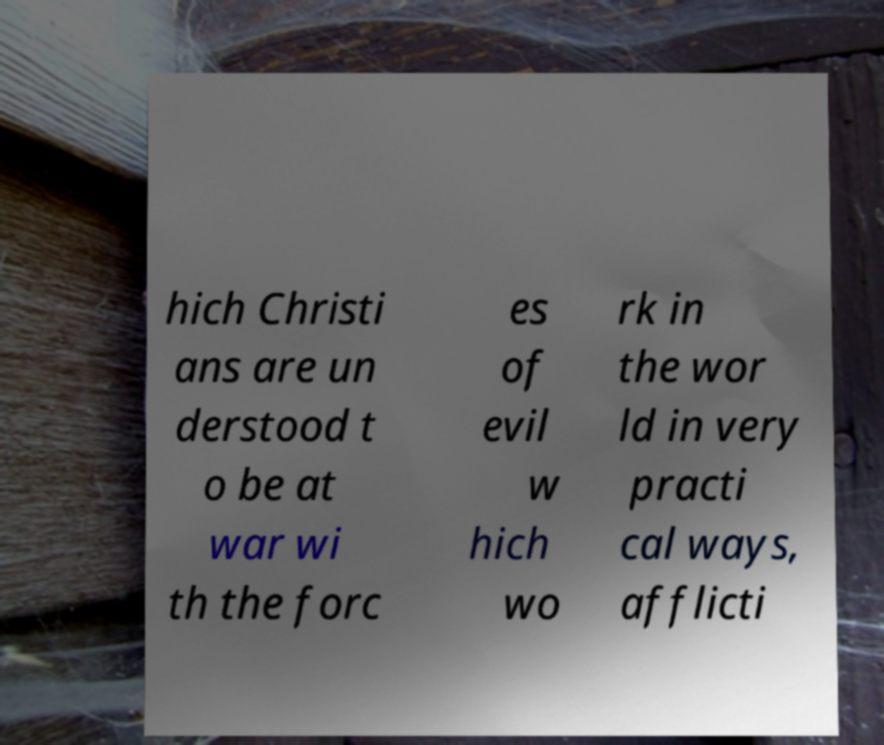Can you accurately transcribe the text from the provided image for me? hich Christi ans are un derstood t o be at war wi th the forc es of evil w hich wo rk in the wor ld in very practi cal ways, afflicti 